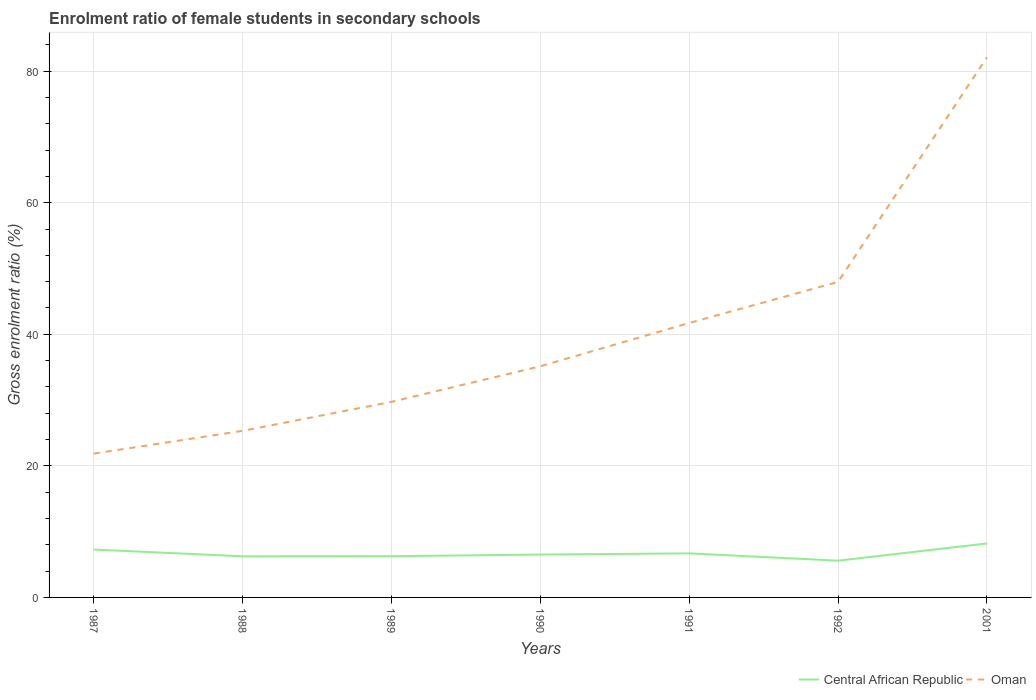Across all years, what is the maximum enrolment ratio of female students in secondary schools in Central African Republic?
Ensure brevity in your answer.  5.59. In which year was the enrolment ratio of female students in secondary schools in Central African Republic maximum?
Your answer should be very brief. 1992. What is the total enrolment ratio of female students in secondary schools in Oman in the graph?
Keep it short and to the point. -3.46. What is the difference between the highest and the second highest enrolment ratio of female students in secondary schools in Central African Republic?
Offer a terse response. 2.62. What is the difference between the highest and the lowest enrolment ratio of female students in secondary schools in Central African Republic?
Ensure brevity in your answer.  3. What is the difference between two consecutive major ticks on the Y-axis?
Ensure brevity in your answer.  20. Does the graph contain any zero values?
Provide a short and direct response. No. Does the graph contain grids?
Your answer should be compact. Yes. Where does the legend appear in the graph?
Offer a very short reply. Bottom right. How many legend labels are there?
Your answer should be very brief. 2. How are the legend labels stacked?
Provide a short and direct response. Horizontal. What is the title of the graph?
Your answer should be very brief. Enrolment ratio of female students in secondary schools. Does "Finland" appear as one of the legend labels in the graph?
Your answer should be very brief. No. What is the label or title of the X-axis?
Make the answer very short. Years. What is the Gross enrolment ratio (%) in Central African Republic in 1987?
Your response must be concise. 7.27. What is the Gross enrolment ratio (%) in Oman in 1987?
Ensure brevity in your answer.  21.86. What is the Gross enrolment ratio (%) of Central African Republic in 1988?
Give a very brief answer. 6.25. What is the Gross enrolment ratio (%) in Oman in 1988?
Offer a terse response. 25.32. What is the Gross enrolment ratio (%) in Central African Republic in 1989?
Give a very brief answer. 6.27. What is the Gross enrolment ratio (%) in Oman in 1989?
Ensure brevity in your answer.  29.73. What is the Gross enrolment ratio (%) in Central African Republic in 1990?
Keep it short and to the point. 6.51. What is the Gross enrolment ratio (%) of Oman in 1990?
Your answer should be compact. 35.14. What is the Gross enrolment ratio (%) in Central African Republic in 1991?
Offer a very short reply. 6.7. What is the Gross enrolment ratio (%) of Oman in 1991?
Your answer should be compact. 41.72. What is the Gross enrolment ratio (%) of Central African Republic in 1992?
Make the answer very short. 5.59. What is the Gross enrolment ratio (%) in Oman in 1992?
Offer a very short reply. 47.96. What is the Gross enrolment ratio (%) in Central African Republic in 2001?
Give a very brief answer. 8.2. What is the Gross enrolment ratio (%) in Oman in 2001?
Ensure brevity in your answer.  82.09. Across all years, what is the maximum Gross enrolment ratio (%) of Central African Republic?
Offer a very short reply. 8.2. Across all years, what is the maximum Gross enrolment ratio (%) of Oman?
Your response must be concise. 82.09. Across all years, what is the minimum Gross enrolment ratio (%) of Central African Republic?
Give a very brief answer. 5.59. Across all years, what is the minimum Gross enrolment ratio (%) of Oman?
Provide a succinct answer. 21.86. What is the total Gross enrolment ratio (%) of Central African Republic in the graph?
Your answer should be compact. 46.8. What is the total Gross enrolment ratio (%) in Oman in the graph?
Give a very brief answer. 283.82. What is the difference between the Gross enrolment ratio (%) of Central African Republic in 1987 and that in 1988?
Make the answer very short. 1.02. What is the difference between the Gross enrolment ratio (%) in Oman in 1987 and that in 1988?
Ensure brevity in your answer.  -3.46. What is the difference between the Gross enrolment ratio (%) of Central African Republic in 1987 and that in 1989?
Provide a succinct answer. 1.01. What is the difference between the Gross enrolment ratio (%) in Oman in 1987 and that in 1989?
Provide a short and direct response. -7.87. What is the difference between the Gross enrolment ratio (%) of Central African Republic in 1987 and that in 1990?
Keep it short and to the point. 0.76. What is the difference between the Gross enrolment ratio (%) in Oman in 1987 and that in 1990?
Your answer should be very brief. -13.27. What is the difference between the Gross enrolment ratio (%) of Central African Republic in 1987 and that in 1991?
Your answer should be compact. 0.58. What is the difference between the Gross enrolment ratio (%) in Oman in 1987 and that in 1991?
Make the answer very short. -19.86. What is the difference between the Gross enrolment ratio (%) of Central African Republic in 1987 and that in 1992?
Keep it short and to the point. 1.69. What is the difference between the Gross enrolment ratio (%) in Oman in 1987 and that in 1992?
Give a very brief answer. -26.09. What is the difference between the Gross enrolment ratio (%) in Central African Republic in 1987 and that in 2001?
Provide a succinct answer. -0.93. What is the difference between the Gross enrolment ratio (%) of Oman in 1987 and that in 2001?
Provide a succinct answer. -60.22. What is the difference between the Gross enrolment ratio (%) of Central African Republic in 1988 and that in 1989?
Keep it short and to the point. -0.01. What is the difference between the Gross enrolment ratio (%) of Oman in 1988 and that in 1989?
Ensure brevity in your answer.  -4.41. What is the difference between the Gross enrolment ratio (%) of Central African Republic in 1988 and that in 1990?
Keep it short and to the point. -0.26. What is the difference between the Gross enrolment ratio (%) in Oman in 1988 and that in 1990?
Your response must be concise. -9.81. What is the difference between the Gross enrolment ratio (%) of Central African Republic in 1988 and that in 1991?
Your answer should be compact. -0.44. What is the difference between the Gross enrolment ratio (%) in Oman in 1988 and that in 1991?
Provide a short and direct response. -16.4. What is the difference between the Gross enrolment ratio (%) of Central African Republic in 1988 and that in 1992?
Ensure brevity in your answer.  0.67. What is the difference between the Gross enrolment ratio (%) in Oman in 1988 and that in 1992?
Provide a short and direct response. -22.63. What is the difference between the Gross enrolment ratio (%) in Central African Republic in 1988 and that in 2001?
Keep it short and to the point. -1.95. What is the difference between the Gross enrolment ratio (%) in Oman in 1988 and that in 2001?
Give a very brief answer. -56.76. What is the difference between the Gross enrolment ratio (%) of Central African Republic in 1989 and that in 1990?
Give a very brief answer. -0.25. What is the difference between the Gross enrolment ratio (%) in Oman in 1989 and that in 1990?
Keep it short and to the point. -5.41. What is the difference between the Gross enrolment ratio (%) in Central African Republic in 1989 and that in 1991?
Your response must be concise. -0.43. What is the difference between the Gross enrolment ratio (%) of Oman in 1989 and that in 1991?
Your response must be concise. -11.99. What is the difference between the Gross enrolment ratio (%) in Central African Republic in 1989 and that in 1992?
Your response must be concise. 0.68. What is the difference between the Gross enrolment ratio (%) of Oman in 1989 and that in 1992?
Your response must be concise. -18.23. What is the difference between the Gross enrolment ratio (%) in Central African Republic in 1989 and that in 2001?
Provide a short and direct response. -1.94. What is the difference between the Gross enrolment ratio (%) in Oman in 1989 and that in 2001?
Provide a succinct answer. -52.36. What is the difference between the Gross enrolment ratio (%) in Central African Republic in 1990 and that in 1991?
Make the answer very short. -0.18. What is the difference between the Gross enrolment ratio (%) in Oman in 1990 and that in 1991?
Your response must be concise. -6.58. What is the difference between the Gross enrolment ratio (%) in Central African Republic in 1990 and that in 1992?
Provide a short and direct response. 0.93. What is the difference between the Gross enrolment ratio (%) of Oman in 1990 and that in 1992?
Ensure brevity in your answer.  -12.82. What is the difference between the Gross enrolment ratio (%) in Central African Republic in 1990 and that in 2001?
Your answer should be very brief. -1.69. What is the difference between the Gross enrolment ratio (%) in Oman in 1990 and that in 2001?
Offer a very short reply. -46.95. What is the difference between the Gross enrolment ratio (%) in Central African Republic in 1991 and that in 1992?
Make the answer very short. 1.11. What is the difference between the Gross enrolment ratio (%) in Oman in 1991 and that in 1992?
Your response must be concise. -6.24. What is the difference between the Gross enrolment ratio (%) of Central African Republic in 1991 and that in 2001?
Provide a short and direct response. -1.51. What is the difference between the Gross enrolment ratio (%) of Oman in 1991 and that in 2001?
Provide a succinct answer. -40.37. What is the difference between the Gross enrolment ratio (%) in Central African Republic in 1992 and that in 2001?
Offer a very short reply. -2.62. What is the difference between the Gross enrolment ratio (%) in Oman in 1992 and that in 2001?
Keep it short and to the point. -34.13. What is the difference between the Gross enrolment ratio (%) of Central African Republic in 1987 and the Gross enrolment ratio (%) of Oman in 1988?
Your answer should be compact. -18.05. What is the difference between the Gross enrolment ratio (%) of Central African Republic in 1987 and the Gross enrolment ratio (%) of Oman in 1989?
Your answer should be very brief. -22.46. What is the difference between the Gross enrolment ratio (%) in Central African Republic in 1987 and the Gross enrolment ratio (%) in Oman in 1990?
Your answer should be very brief. -27.86. What is the difference between the Gross enrolment ratio (%) in Central African Republic in 1987 and the Gross enrolment ratio (%) in Oman in 1991?
Provide a short and direct response. -34.45. What is the difference between the Gross enrolment ratio (%) in Central African Republic in 1987 and the Gross enrolment ratio (%) in Oman in 1992?
Provide a succinct answer. -40.68. What is the difference between the Gross enrolment ratio (%) of Central African Republic in 1987 and the Gross enrolment ratio (%) of Oman in 2001?
Offer a very short reply. -74.81. What is the difference between the Gross enrolment ratio (%) in Central African Republic in 1988 and the Gross enrolment ratio (%) in Oman in 1989?
Your response must be concise. -23.48. What is the difference between the Gross enrolment ratio (%) of Central African Republic in 1988 and the Gross enrolment ratio (%) of Oman in 1990?
Provide a short and direct response. -28.88. What is the difference between the Gross enrolment ratio (%) of Central African Republic in 1988 and the Gross enrolment ratio (%) of Oman in 1991?
Give a very brief answer. -35.47. What is the difference between the Gross enrolment ratio (%) in Central African Republic in 1988 and the Gross enrolment ratio (%) in Oman in 1992?
Offer a very short reply. -41.7. What is the difference between the Gross enrolment ratio (%) of Central African Republic in 1988 and the Gross enrolment ratio (%) of Oman in 2001?
Your response must be concise. -75.83. What is the difference between the Gross enrolment ratio (%) in Central African Republic in 1989 and the Gross enrolment ratio (%) in Oman in 1990?
Give a very brief answer. -28.87. What is the difference between the Gross enrolment ratio (%) of Central African Republic in 1989 and the Gross enrolment ratio (%) of Oman in 1991?
Ensure brevity in your answer.  -35.46. What is the difference between the Gross enrolment ratio (%) of Central African Republic in 1989 and the Gross enrolment ratio (%) of Oman in 1992?
Make the answer very short. -41.69. What is the difference between the Gross enrolment ratio (%) in Central African Republic in 1989 and the Gross enrolment ratio (%) in Oman in 2001?
Make the answer very short. -75.82. What is the difference between the Gross enrolment ratio (%) in Central African Republic in 1990 and the Gross enrolment ratio (%) in Oman in 1991?
Your answer should be very brief. -35.21. What is the difference between the Gross enrolment ratio (%) of Central African Republic in 1990 and the Gross enrolment ratio (%) of Oman in 1992?
Your response must be concise. -41.44. What is the difference between the Gross enrolment ratio (%) in Central African Republic in 1990 and the Gross enrolment ratio (%) in Oman in 2001?
Your answer should be compact. -75.57. What is the difference between the Gross enrolment ratio (%) in Central African Republic in 1991 and the Gross enrolment ratio (%) in Oman in 1992?
Your answer should be very brief. -41.26. What is the difference between the Gross enrolment ratio (%) in Central African Republic in 1991 and the Gross enrolment ratio (%) in Oman in 2001?
Give a very brief answer. -75.39. What is the difference between the Gross enrolment ratio (%) in Central African Republic in 1992 and the Gross enrolment ratio (%) in Oman in 2001?
Offer a very short reply. -76.5. What is the average Gross enrolment ratio (%) in Central African Republic per year?
Your response must be concise. 6.69. What is the average Gross enrolment ratio (%) in Oman per year?
Your answer should be compact. 40.55. In the year 1987, what is the difference between the Gross enrolment ratio (%) in Central African Republic and Gross enrolment ratio (%) in Oman?
Your answer should be compact. -14.59. In the year 1988, what is the difference between the Gross enrolment ratio (%) of Central African Republic and Gross enrolment ratio (%) of Oman?
Your answer should be very brief. -19.07. In the year 1989, what is the difference between the Gross enrolment ratio (%) of Central African Republic and Gross enrolment ratio (%) of Oman?
Provide a short and direct response. -23.46. In the year 1990, what is the difference between the Gross enrolment ratio (%) in Central African Republic and Gross enrolment ratio (%) in Oman?
Your response must be concise. -28.62. In the year 1991, what is the difference between the Gross enrolment ratio (%) in Central African Republic and Gross enrolment ratio (%) in Oman?
Provide a short and direct response. -35.02. In the year 1992, what is the difference between the Gross enrolment ratio (%) in Central African Republic and Gross enrolment ratio (%) in Oman?
Ensure brevity in your answer.  -42.37. In the year 2001, what is the difference between the Gross enrolment ratio (%) in Central African Republic and Gross enrolment ratio (%) in Oman?
Make the answer very short. -73.88. What is the ratio of the Gross enrolment ratio (%) in Central African Republic in 1987 to that in 1988?
Your response must be concise. 1.16. What is the ratio of the Gross enrolment ratio (%) of Oman in 1987 to that in 1988?
Offer a very short reply. 0.86. What is the ratio of the Gross enrolment ratio (%) of Central African Republic in 1987 to that in 1989?
Keep it short and to the point. 1.16. What is the ratio of the Gross enrolment ratio (%) in Oman in 1987 to that in 1989?
Your response must be concise. 0.74. What is the ratio of the Gross enrolment ratio (%) in Central African Republic in 1987 to that in 1990?
Give a very brief answer. 1.12. What is the ratio of the Gross enrolment ratio (%) of Oman in 1987 to that in 1990?
Make the answer very short. 0.62. What is the ratio of the Gross enrolment ratio (%) in Central African Republic in 1987 to that in 1991?
Your response must be concise. 1.09. What is the ratio of the Gross enrolment ratio (%) of Oman in 1987 to that in 1991?
Your answer should be compact. 0.52. What is the ratio of the Gross enrolment ratio (%) in Central African Republic in 1987 to that in 1992?
Keep it short and to the point. 1.3. What is the ratio of the Gross enrolment ratio (%) of Oman in 1987 to that in 1992?
Your answer should be very brief. 0.46. What is the ratio of the Gross enrolment ratio (%) of Central African Republic in 1987 to that in 2001?
Your answer should be very brief. 0.89. What is the ratio of the Gross enrolment ratio (%) of Oman in 1987 to that in 2001?
Ensure brevity in your answer.  0.27. What is the ratio of the Gross enrolment ratio (%) of Central African Republic in 1988 to that in 1989?
Your response must be concise. 1. What is the ratio of the Gross enrolment ratio (%) in Oman in 1988 to that in 1989?
Your answer should be compact. 0.85. What is the ratio of the Gross enrolment ratio (%) of Central African Republic in 1988 to that in 1990?
Your answer should be very brief. 0.96. What is the ratio of the Gross enrolment ratio (%) in Oman in 1988 to that in 1990?
Make the answer very short. 0.72. What is the ratio of the Gross enrolment ratio (%) of Central African Republic in 1988 to that in 1991?
Keep it short and to the point. 0.93. What is the ratio of the Gross enrolment ratio (%) in Oman in 1988 to that in 1991?
Your answer should be very brief. 0.61. What is the ratio of the Gross enrolment ratio (%) in Central African Republic in 1988 to that in 1992?
Keep it short and to the point. 1.12. What is the ratio of the Gross enrolment ratio (%) in Oman in 1988 to that in 1992?
Make the answer very short. 0.53. What is the ratio of the Gross enrolment ratio (%) of Central African Republic in 1988 to that in 2001?
Make the answer very short. 0.76. What is the ratio of the Gross enrolment ratio (%) in Oman in 1988 to that in 2001?
Provide a succinct answer. 0.31. What is the ratio of the Gross enrolment ratio (%) in Central African Republic in 1989 to that in 1990?
Offer a very short reply. 0.96. What is the ratio of the Gross enrolment ratio (%) of Oman in 1989 to that in 1990?
Ensure brevity in your answer.  0.85. What is the ratio of the Gross enrolment ratio (%) in Central African Republic in 1989 to that in 1991?
Your response must be concise. 0.94. What is the ratio of the Gross enrolment ratio (%) in Oman in 1989 to that in 1991?
Offer a very short reply. 0.71. What is the ratio of the Gross enrolment ratio (%) in Central African Republic in 1989 to that in 1992?
Ensure brevity in your answer.  1.12. What is the ratio of the Gross enrolment ratio (%) in Oman in 1989 to that in 1992?
Give a very brief answer. 0.62. What is the ratio of the Gross enrolment ratio (%) in Central African Republic in 1989 to that in 2001?
Provide a succinct answer. 0.76. What is the ratio of the Gross enrolment ratio (%) of Oman in 1989 to that in 2001?
Keep it short and to the point. 0.36. What is the ratio of the Gross enrolment ratio (%) in Central African Republic in 1990 to that in 1991?
Give a very brief answer. 0.97. What is the ratio of the Gross enrolment ratio (%) of Oman in 1990 to that in 1991?
Keep it short and to the point. 0.84. What is the ratio of the Gross enrolment ratio (%) in Central African Republic in 1990 to that in 1992?
Your answer should be compact. 1.17. What is the ratio of the Gross enrolment ratio (%) of Oman in 1990 to that in 1992?
Ensure brevity in your answer.  0.73. What is the ratio of the Gross enrolment ratio (%) in Central African Republic in 1990 to that in 2001?
Make the answer very short. 0.79. What is the ratio of the Gross enrolment ratio (%) of Oman in 1990 to that in 2001?
Offer a terse response. 0.43. What is the ratio of the Gross enrolment ratio (%) in Central African Republic in 1991 to that in 1992?
Give a very brief answer. 1.2. What is the ratio of the Gross enrolment ratio (%) in Oman in 1991 to that in 1992?
Give a very brief answer. 0.87. What is the ratio of the Gross enrolment ratio (%) in Central African Republic in 1991 to that in 2001?
Give a very brief answer. 0.82. What is the ratio of the Gross enrolment ratio (%) of Oman in 1991 to that in 2001?
Provide a short and direct response. 0.51. What is the ratio of the Gross enrolment ratio (%) of Central African Republic in 1992 to that in 2001?
Provide a succinct answer. 0.68. What is the ratio of the Gross enrolment ratio (%) of Oman in 1992 to that in 2001?
Your response must be concise. 0.58. What is the difference between the highest and the second highest Gross enrolment ratio (%) of Central African Republic?
Your response must be concise. 0.93. What is the difference between the highest and the second highest Gross enrolment ratio (%) in Oman?
Your answer should be compact. 34.13. What is the difference between the highest and the lowest Gross enrolment ratio (%) in Central African Republic?
Ensure brevity in your answer.  2.62. What is the difference between the highest and the lowest Gross enrolment ratio (%) of Oman?
Ensure brevity in your answer.  60.22. 